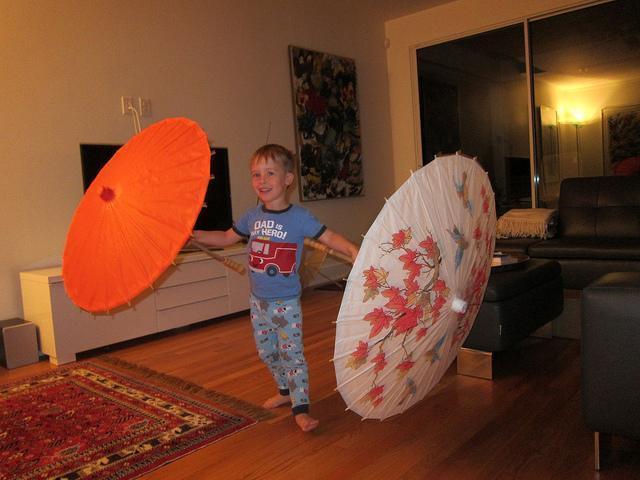How many umbrellas are there?
Give a very brief answer. 2. How many couches are there?
Give a very brief answer. 2. How many umbrellas are in the picture?
Give a very brief answer. 2. How many drinks cups have straw?
Give a very brief answer. 0. 